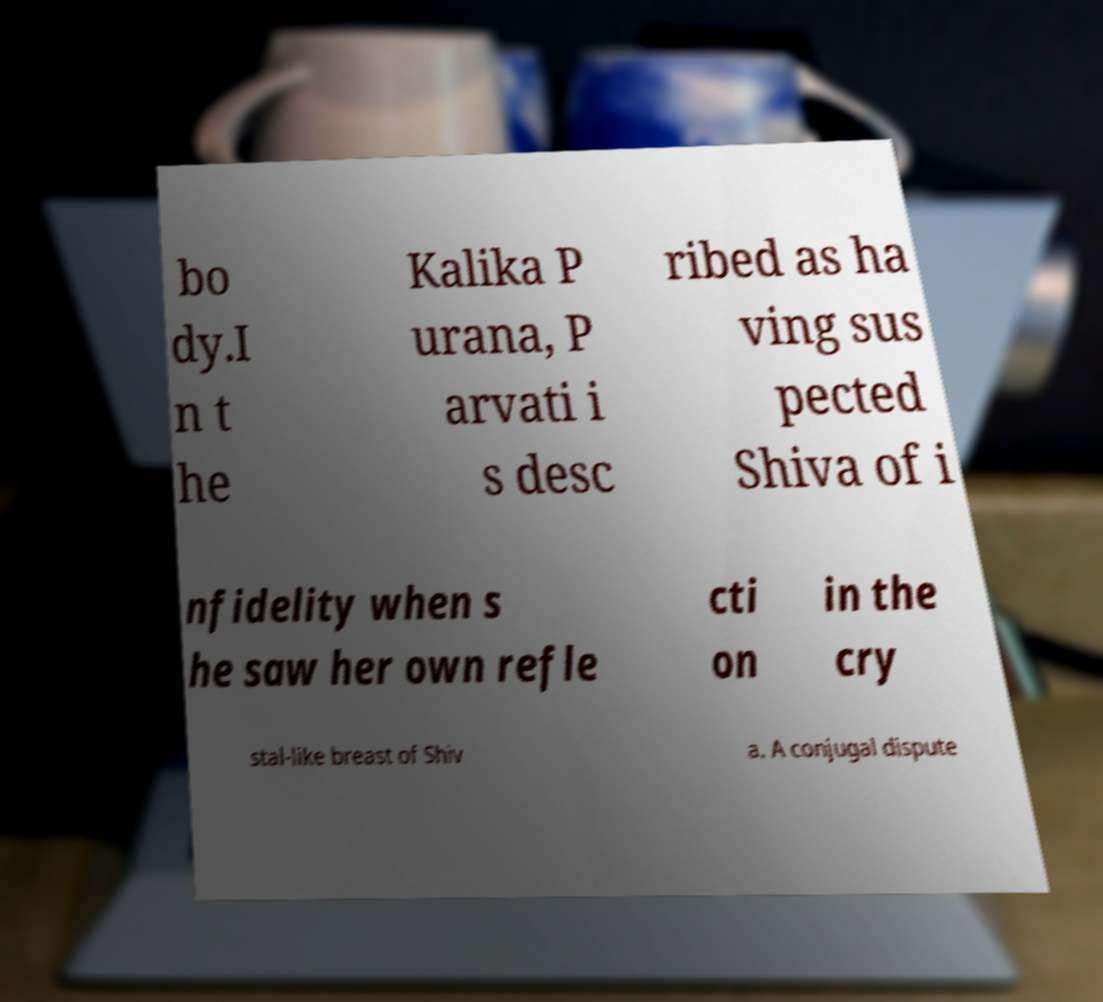Please identify and transcribe the text found in this image. bo dy.I n t he Kalika P urana, P arvati i s desc ribed as ha ving sus pected Shiva of i nfidelity when s he saw her own refle cti on in the cry stal-like breast of Shiv a. A conjugal dispute 